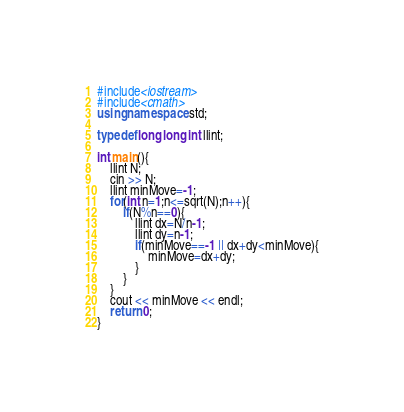<code> <loc_0><loc_0><loc_500><loc_500><_C++_>#include<iostream>
#include<cmath>
using namespace std;

typedef long long int llint;

int main(){
	llint N;
	cin >> N;
	llint minMove=-1;
	for(int n=1;n<=sqrt(N);n++){
		if(N%n==0){
			llint dx=N/n-1;
			llint dy=n-1;
			if(minMove==-1 || dx+dy<minMove){
				minMove=dx+dy;
			}
		}
	}
	cout << minMove << endl;
	return 0;
}
</code> 